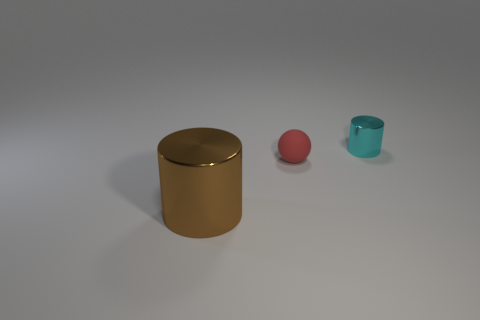Can you describe the lighting and atmosphere of the scene depicted in the image? The image showcases a soft, diffuse lighting condition, likely from an overhead source, creating subtle shadows directly beneath the objects. This suggests an indoor setting with controlled lighting. The smooth, shadowless background gives the image a clean and minimalistic atmosphere, focusing attention on the objects. 